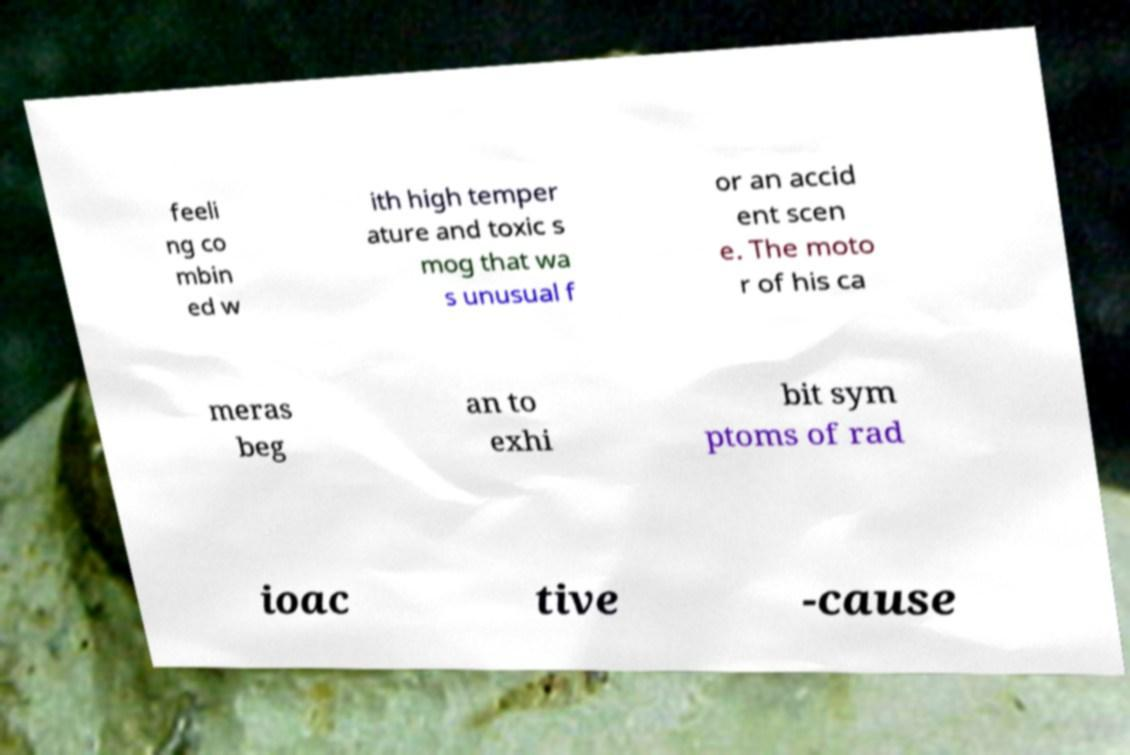Please identify and transcribe the text found in this image. feeli ng co mbin ed w ith high temper ature and toxic s mog that wa s unusual f or an accid ent scen e. The moto r of his ca meras beg an to exhi bit sym ptoms of rad ioac tive -cause 